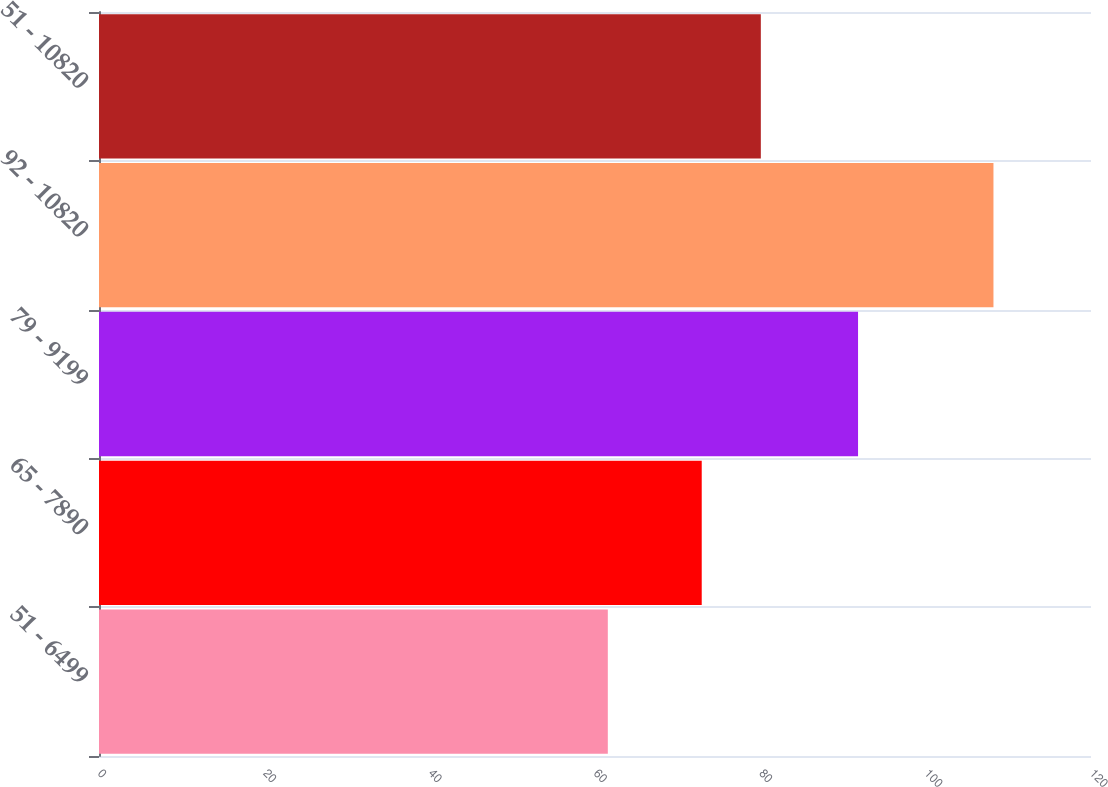Convert chart to OTSL. <chart><loc_0><loc_0><loc_500><loc_500><bar_chart><fcel>51 - 6499<fcel>65 - 7890<fcel>79 - 9199<fcel>92 - 10820<fcel>51 - 10820<nl><fcel>61.55<fcel>72.91<fcel>91.82<fcel>108.2<fcel>80.06<nl></chart> 